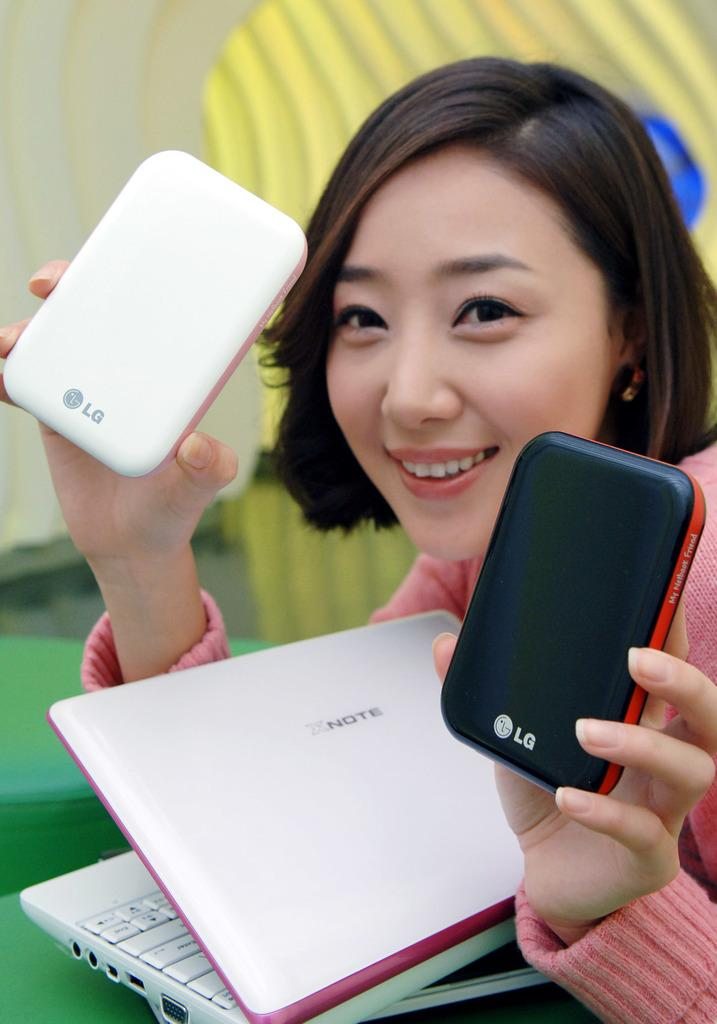<image>
Give a short and clear explanation of the subsequent image. a laptop that has the brand name 'note' on it 